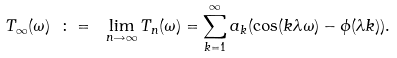Convert formula to latex. <formula><loc_0><loc_0><loc_500><loc_500>T _ { \infty } ( \omega ) \ \colon = \ \lim _ { n \rightarrow \infty } T _ { n } ( \omega ) = \sum _ { k = 1 } ^ { \infty } a _ { k } ( \cos ( k \lambda \omega ) - \phi ( \lambda k ) ) .</formula> 